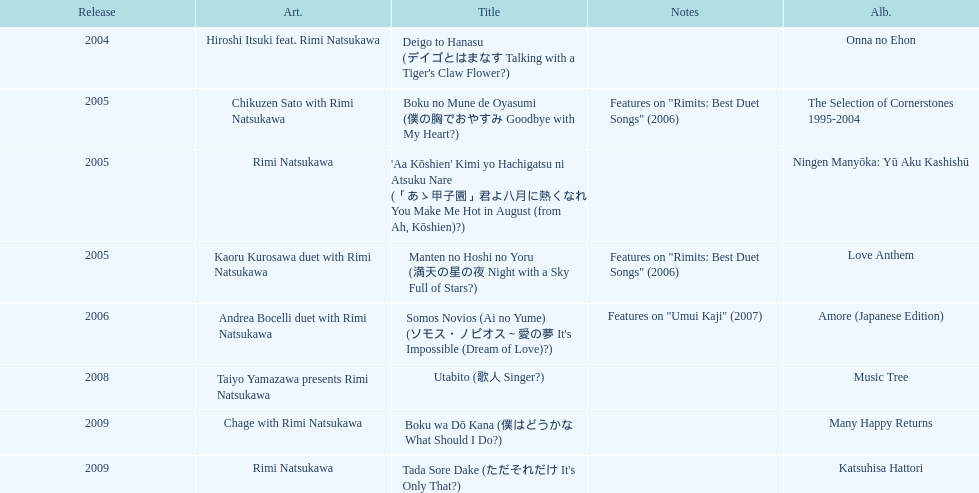What has been the last song this artist has made an other appearance on? Tada Sore Dake. 